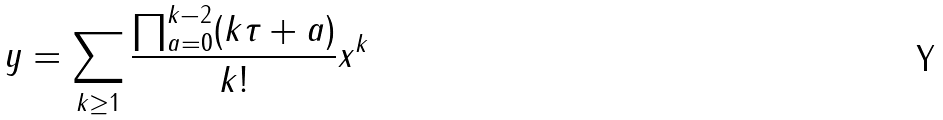<formula> <loc_0><loc_0><loc_500><loc_500>y = \sum _ { k \geq 1 } \frac { \prod _ { a = 0 } ^ { k - 2 } ( k \tau + a ) } { k ! } x ^ { k }</formula> 